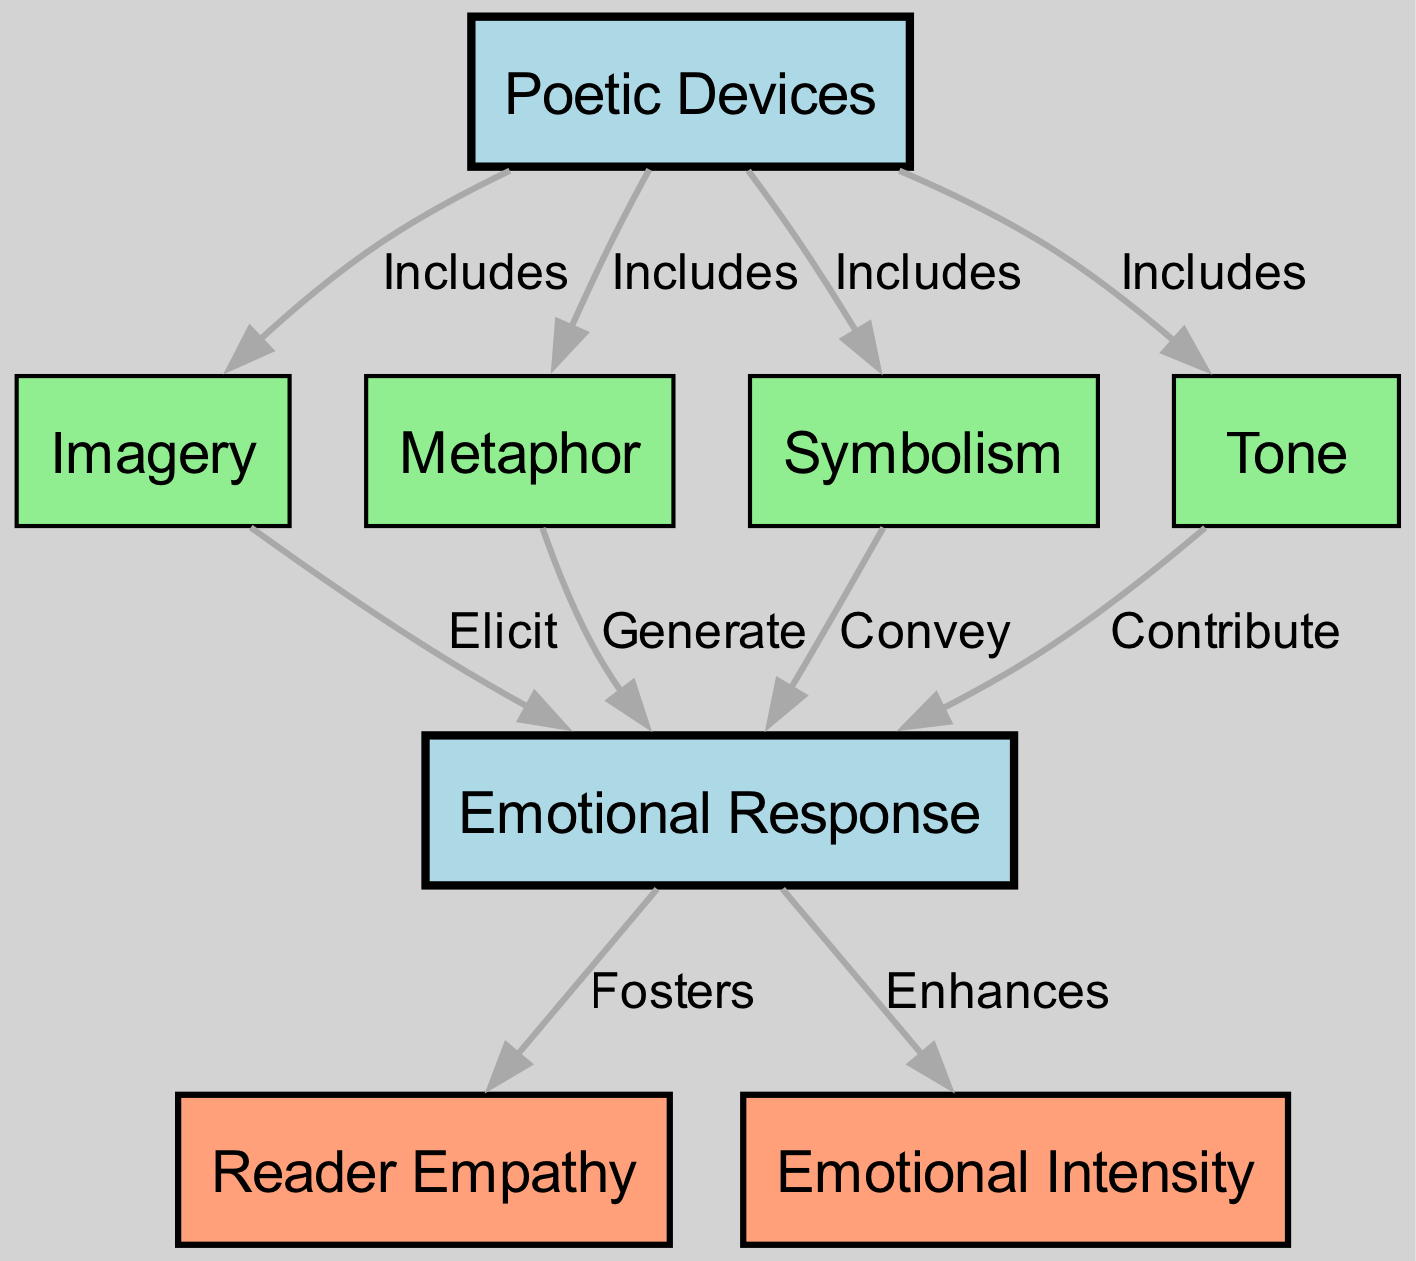What are the main categories included under Poetic Devices? The diagram shows that Poetic Devices includes Imagery, Metaphor, Symbolism, and Tone. I identify these categories by looking directly at the edges that connect Poetic Devices to other nodes labeled as these specific categories.
Answer: Imagery, Metaphor, Symbolism, Tone How many edges connect Poetic Devices to other nodes? By examining the diagram, I count the lines that originate from the node Poetic Devices, which connect it to four different nodes (Imagery, Metaphor, Symbolism, Tone). Therefore, there are four edges originating from it.
Answer: 4 What is the relationship between Imagery and Emotional Response? According to the diagram, the edge connecting Imagery to Emotional Response is labeled "Elicit," indicating the type of influence Imagery has on Emotional Response. I conclude this by checking the edge connecting these two nodes.
Answer: Elicit Which poetic device is described as enhancing emotional intensity? The diagram indicates that emotional intensity is influenced by emotional response and highlights its connection by showing an edge labeled "Enhances" from Emotional Response to Emotional Intensity. This relationship suggests that the emotional response enhances emotional intensity.
Answer: Emotional Response What does Symbolism do to Emotional Response? The diagram indicates that Symbolism has a relationship with Emotional Response, marked by the label "Convey." This means that Symbolism specifically conveys aspects of Emotional Response, as shown in the edge connecting these two nodes.
Answer: Convey How does Tone influence Emotional Response? The diagram shows that Tone contributes to Emotional Response, as per the edge labeled "Contribute" that connects Tone to Emotional Response. Therefore, the influence of Tone is characterized by this specific contribution.
Answer: Contribute What effect does Emotional Response have on Reader Empathy? The relationship depicted in the diagram shows that Emotional Response fosters Reader Empathy, indicated by the edge labeled "Fosters" connecting these two nodes. I draw this conclusion by observing the direct link between Emotional Response and Reader Empathy.
Answer: Fosters Which poetic device is responsible for generating emotional responses? The diagram specifies that Metaphor generates emotional responses, as indicated by the edge labeled "Generate" connecting the Metaphor node to the Emotional Response node. I arrive at this conclusion by directly referencing the edge associated with Metaphor.
Answer: Generate What emotional effect does the use of Poetic Devices have? The diagram shows that Poetic Devices influence Emotional Response, which in turn enhances Emotional Intensity, thus indicating that the use of Poetic Devices collectively leads to heightened emotional experiences. This is derived from observing the interconnectedness of the nodes.
Answer: Enhances Emotional Intensity 